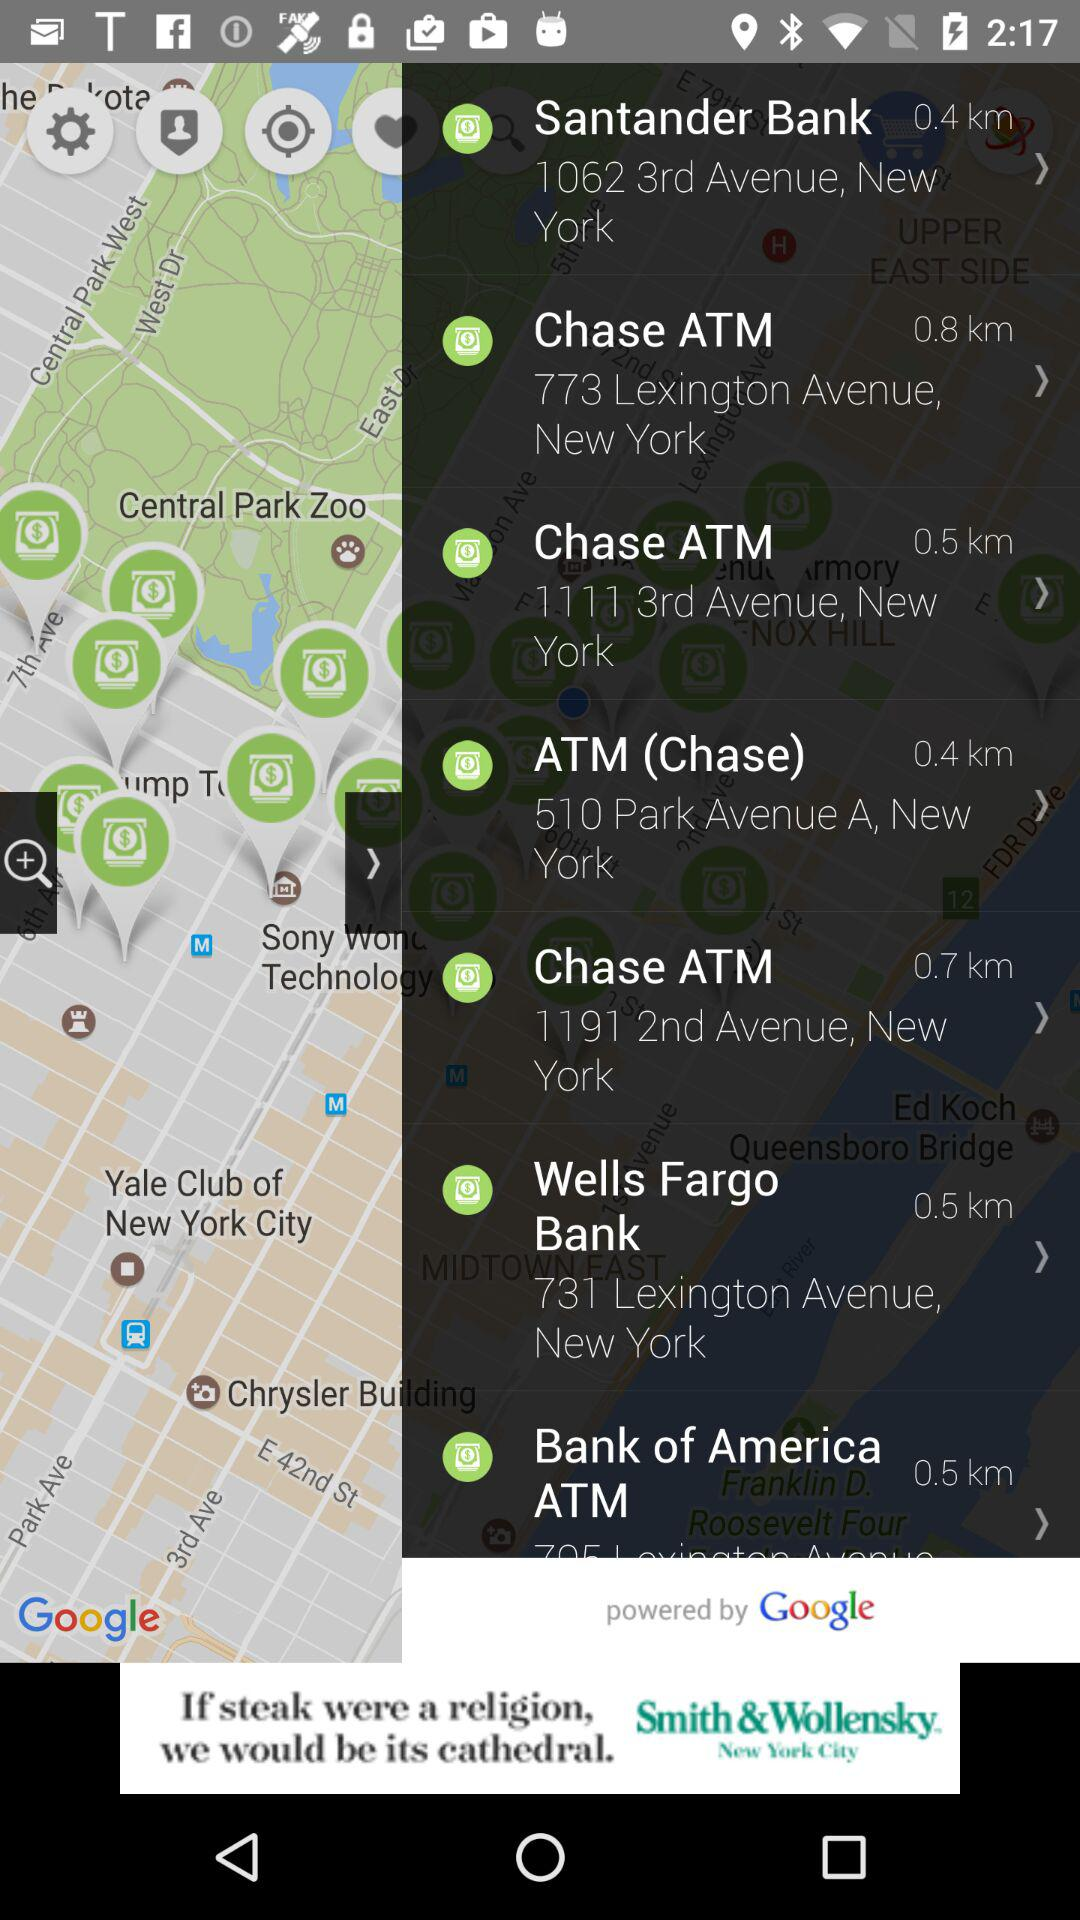What is the distance to "Chase ATM" at 773 Lexington Avenue, New York? The distance to "Chase ATM" at 773 Lexington Avenue, New York, is 0.8 km. 